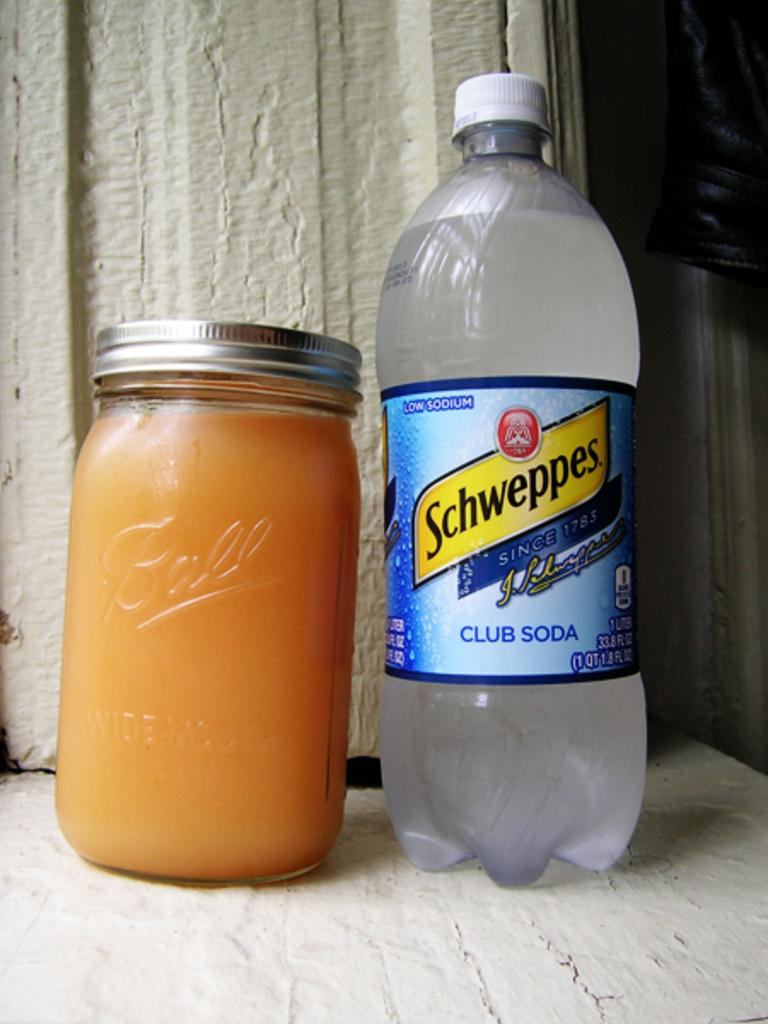<image>
Share a concise interpretation of the image provided. A plastic bottle of Schweppes club soda sits beside a Ball jar filled with an orange liquid. 